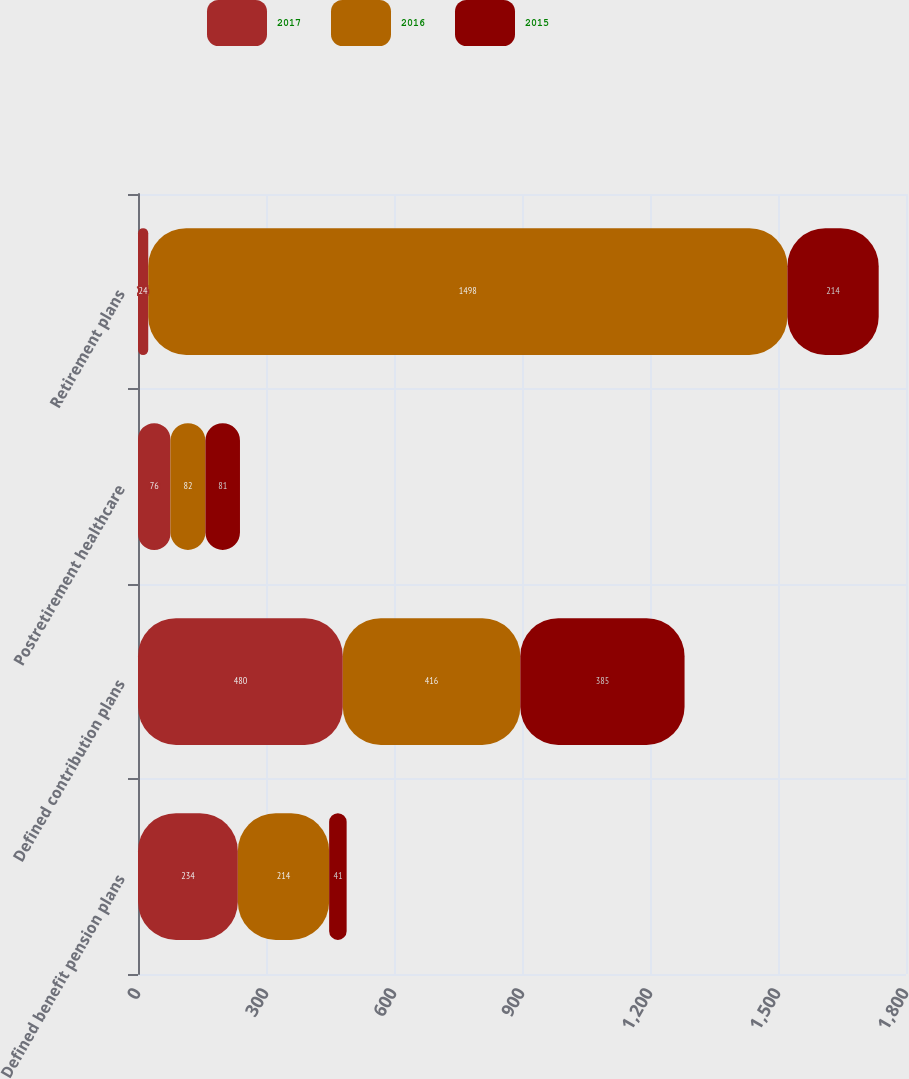Convert chart to OTSL. <chart><loc_0><loc_0><loc_500><loc_500><stacked_bar_chart><ecel><fcel>Defined benefit pension plans<fcel>Defined contribution plans<fcel>Postretirement healthcare<fcel>Retirement plans<nl><fcel>2017<fcel>234<fcel>480<fcel>76<fcel>24<nl><fcel>2016<fcel>214<fcel>416<fcel>82<fcel>1498<nl><fcel>2015<fcel>41<fcel>385<fcel>81<fcel>214<nl></chart> 